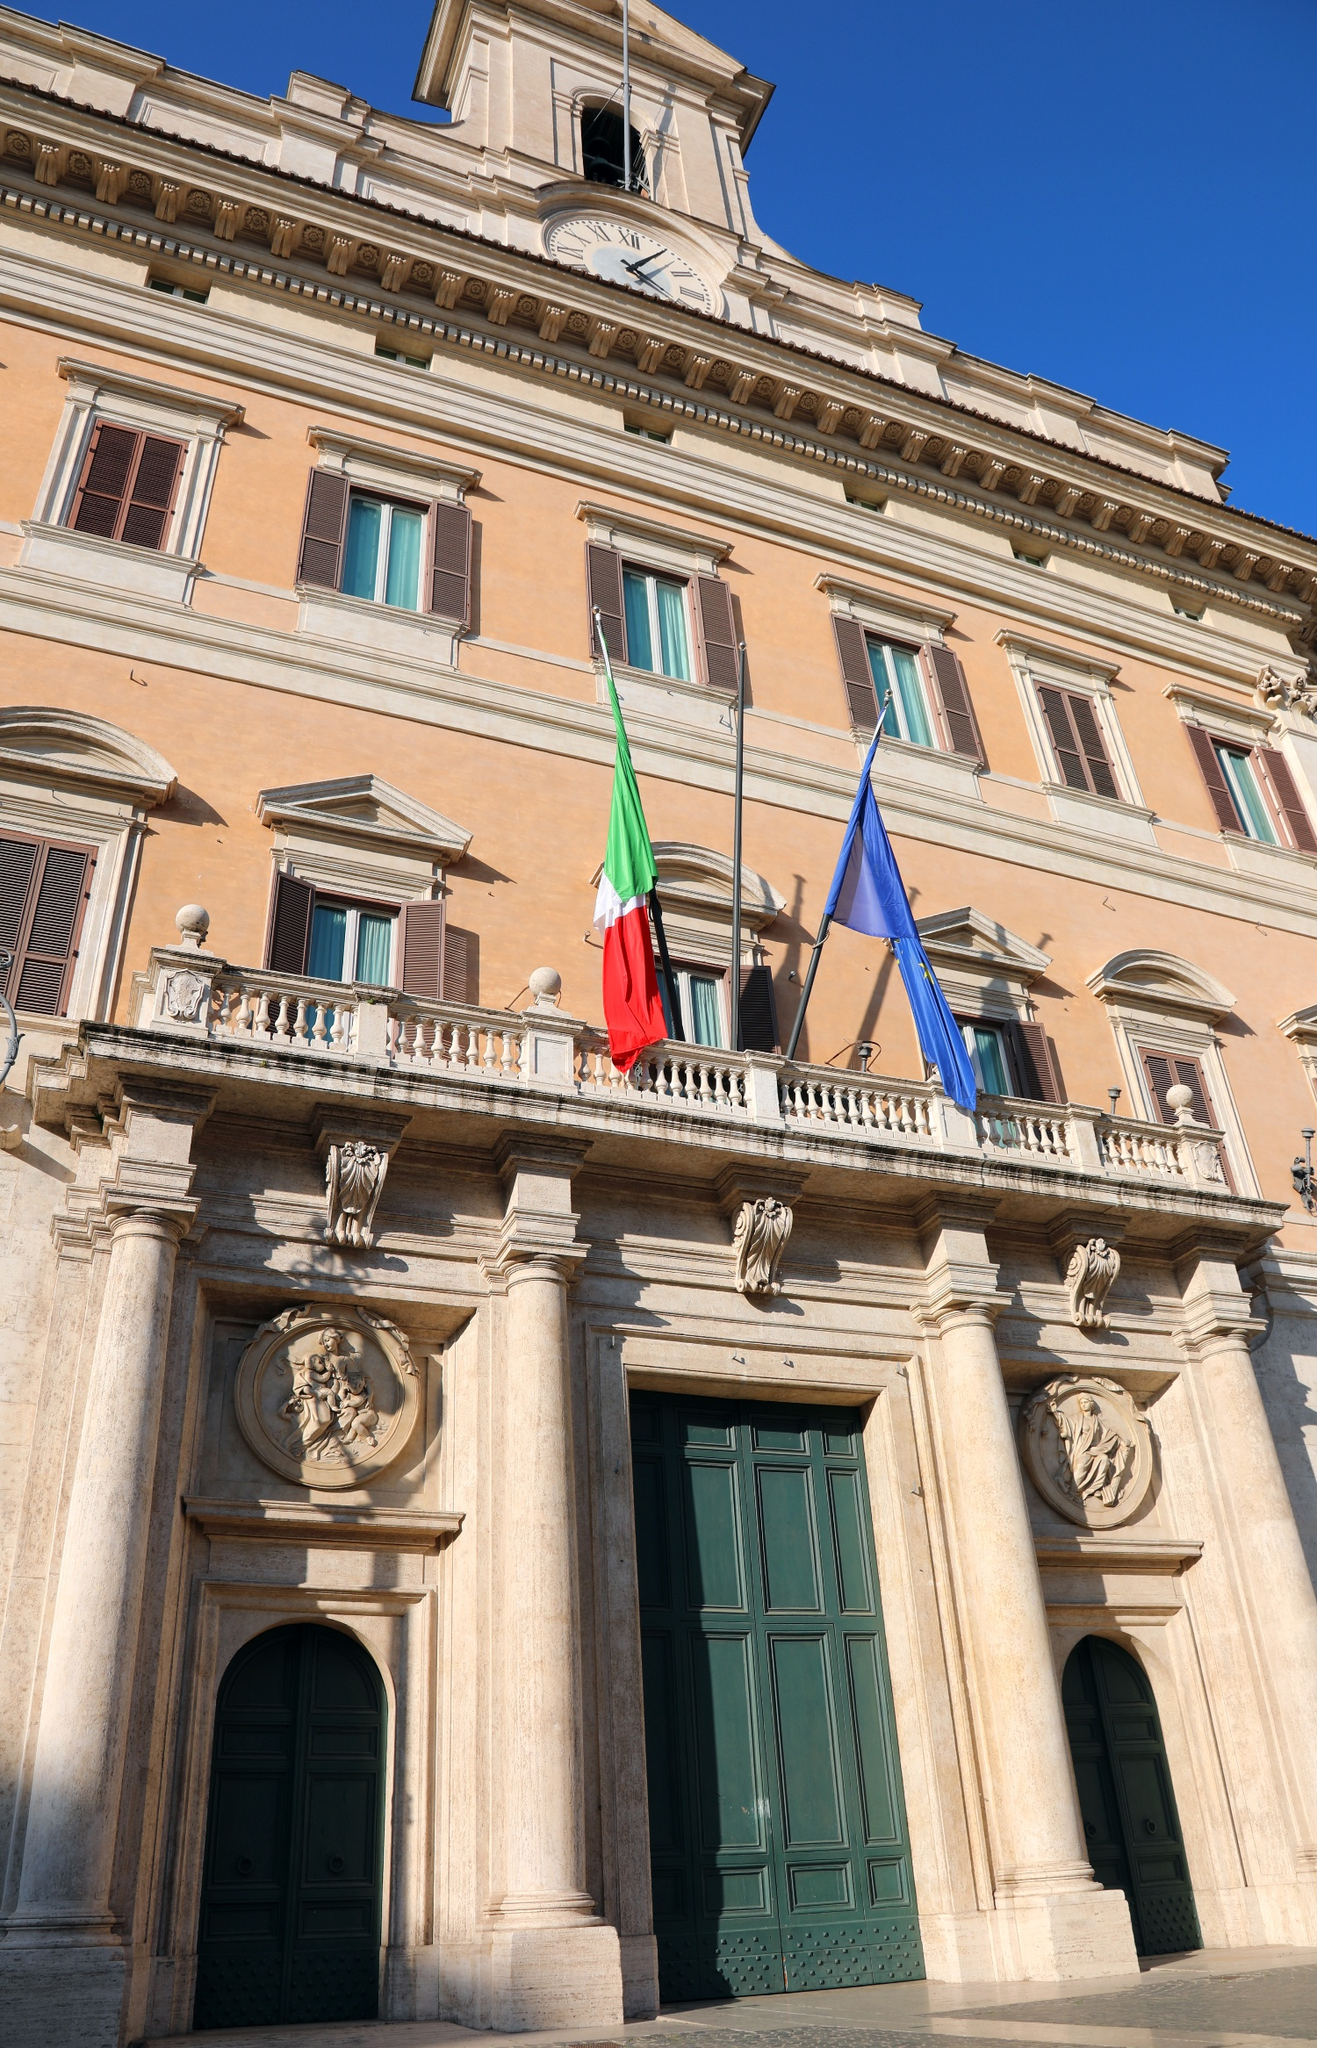Analyze the image in a comprehensive and detailed manner. The image captures the grandeur of the Palazzo Montecitorio, the seat of the Italian Chamber of Deputies. This three-story structure, bathed in a soft, pale orange hue, stands tall against the backdrop of a clear blue sky. The building is adorned with a clock tower at its zenith, silently keeping time over the bustling city below. At the front of the building, the Italian and European Union flags flutter in the wind, symbolizing the nation's identity and its connection to the broader European community. The perspective of the photo, taken from a low angle, enhances the imposing stature of the building, inviting viewers to appreciate its architectural beauty and historical significance. The image code "sa_10926" might be useful for further identification or research. 